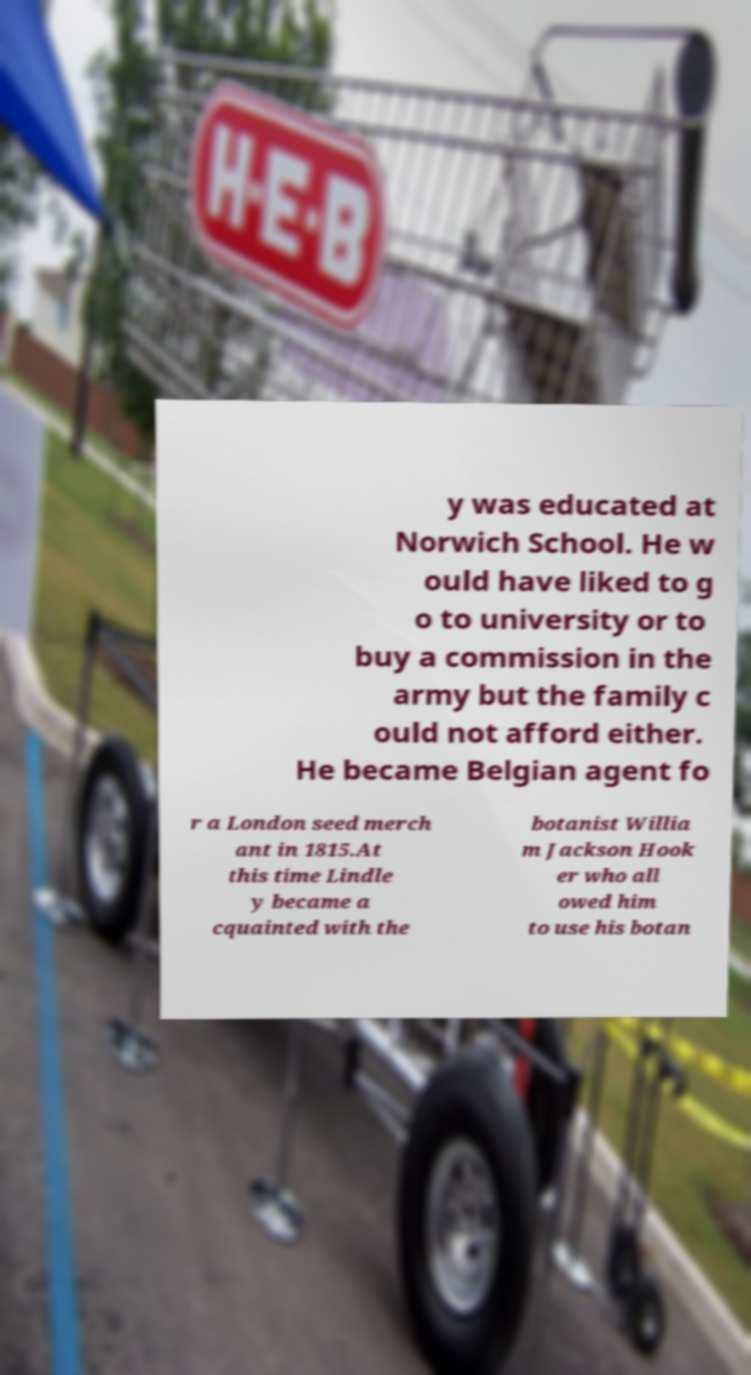There's text embedded in this image that I need extracted. Can you transcribe it verbatim? y was educated at Norwich School. He w ould have liked to g o to university or to buy a commission in the army but the family c ould not afford either. He became Belgian agent fo r a London seed merch ant in 1815.At this time Lindle y became a cquainted with the botanist Willia m Jackson Hook er who all owed him to use his botan 